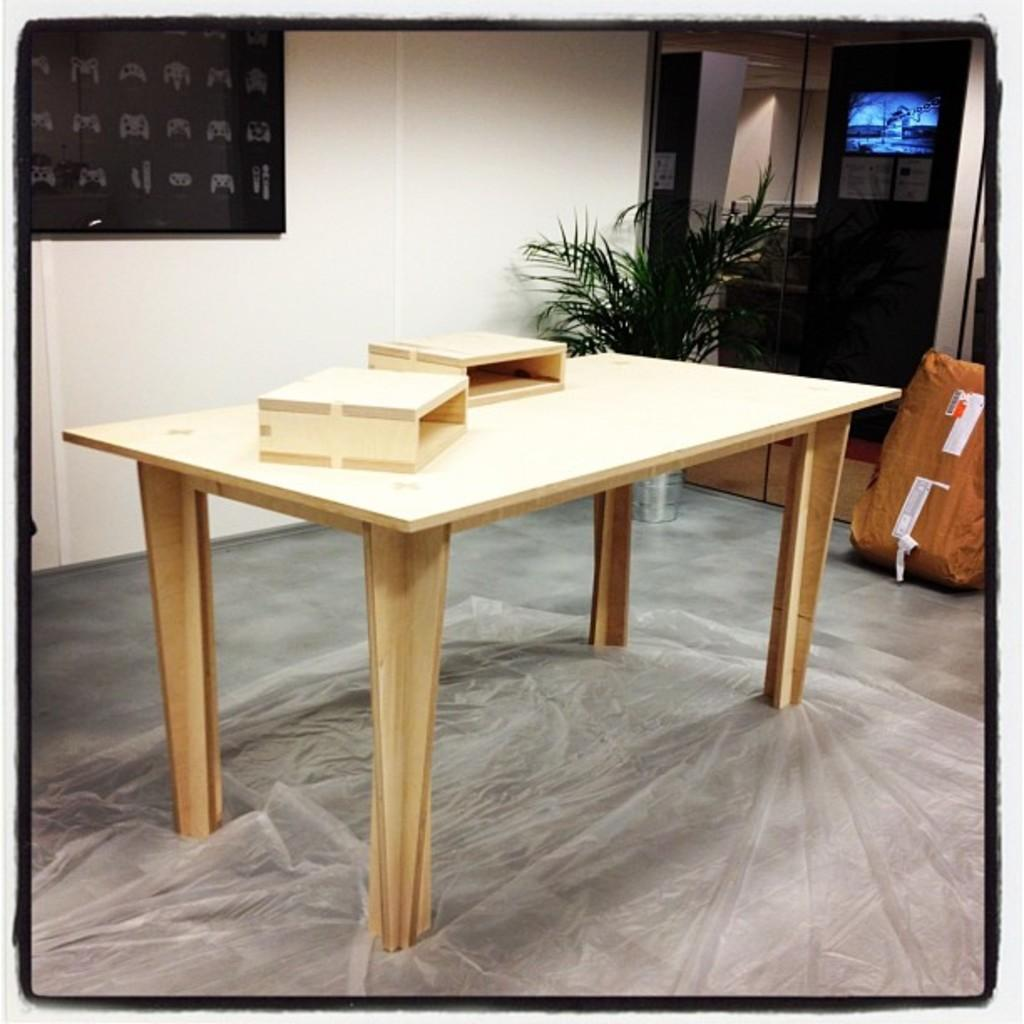What is the color of the wall in the image? The wall in the image is white. What piece of furniture is present in the image? There is a table in the image. What is placed on the table in the image? There is a cover on the table in the image. What type of living organism can be seen in the image? There is a plant in the image. What architectural feature is visible in the image? There is a door in the image. What type of toy is being used to kiss the plant in the image? There is no toy or kissing action present in the image; it only features a plant on a table. 